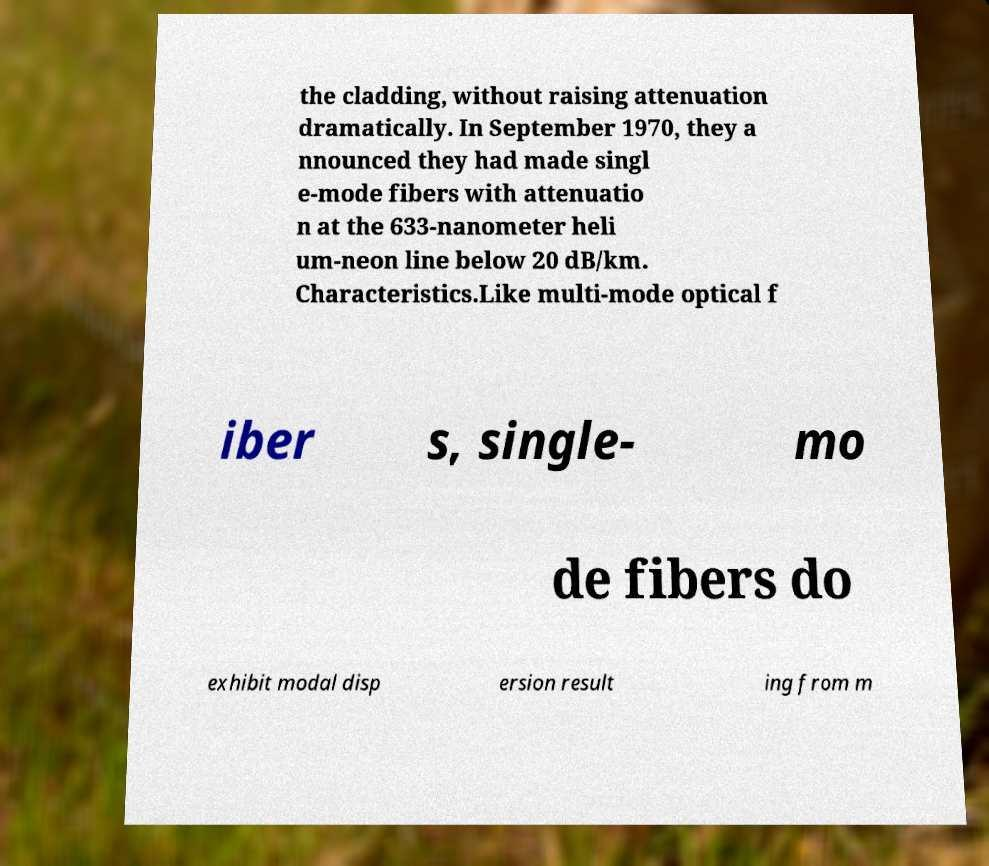There's text embedded in this image that I need extracted. Can you transcribe it verbatim? the cladding, without raising attenuation dramatically. In September 1970, they a nnounced they had made singl e-mode fibers with attenuatio n at the 633-nanometer heli um-neon line below 20 dB/km. Characteristics.Like multi-mode optical f iber s, single- mo de fibers do exhibit modal disp ersion result ing from m 